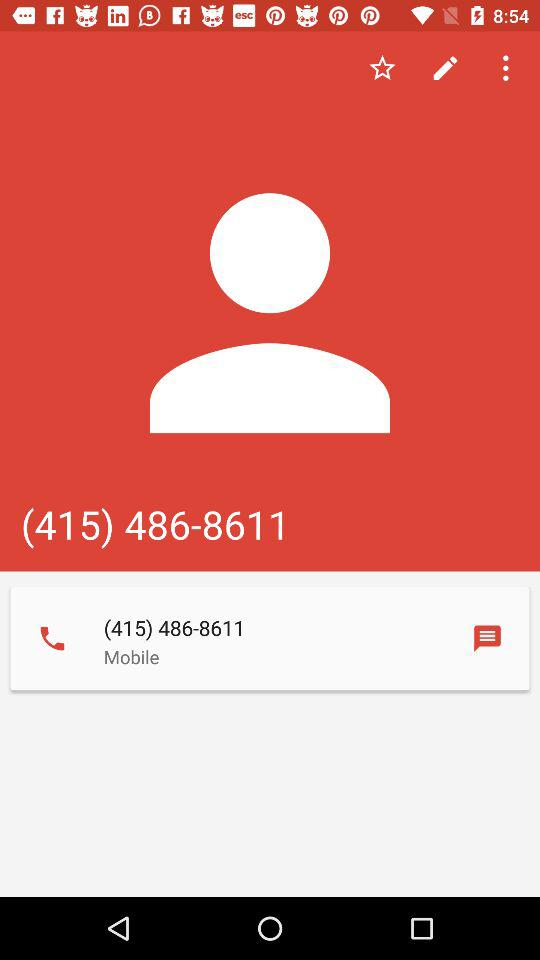What is the phone number? The phone number is (415) 486-8611. 